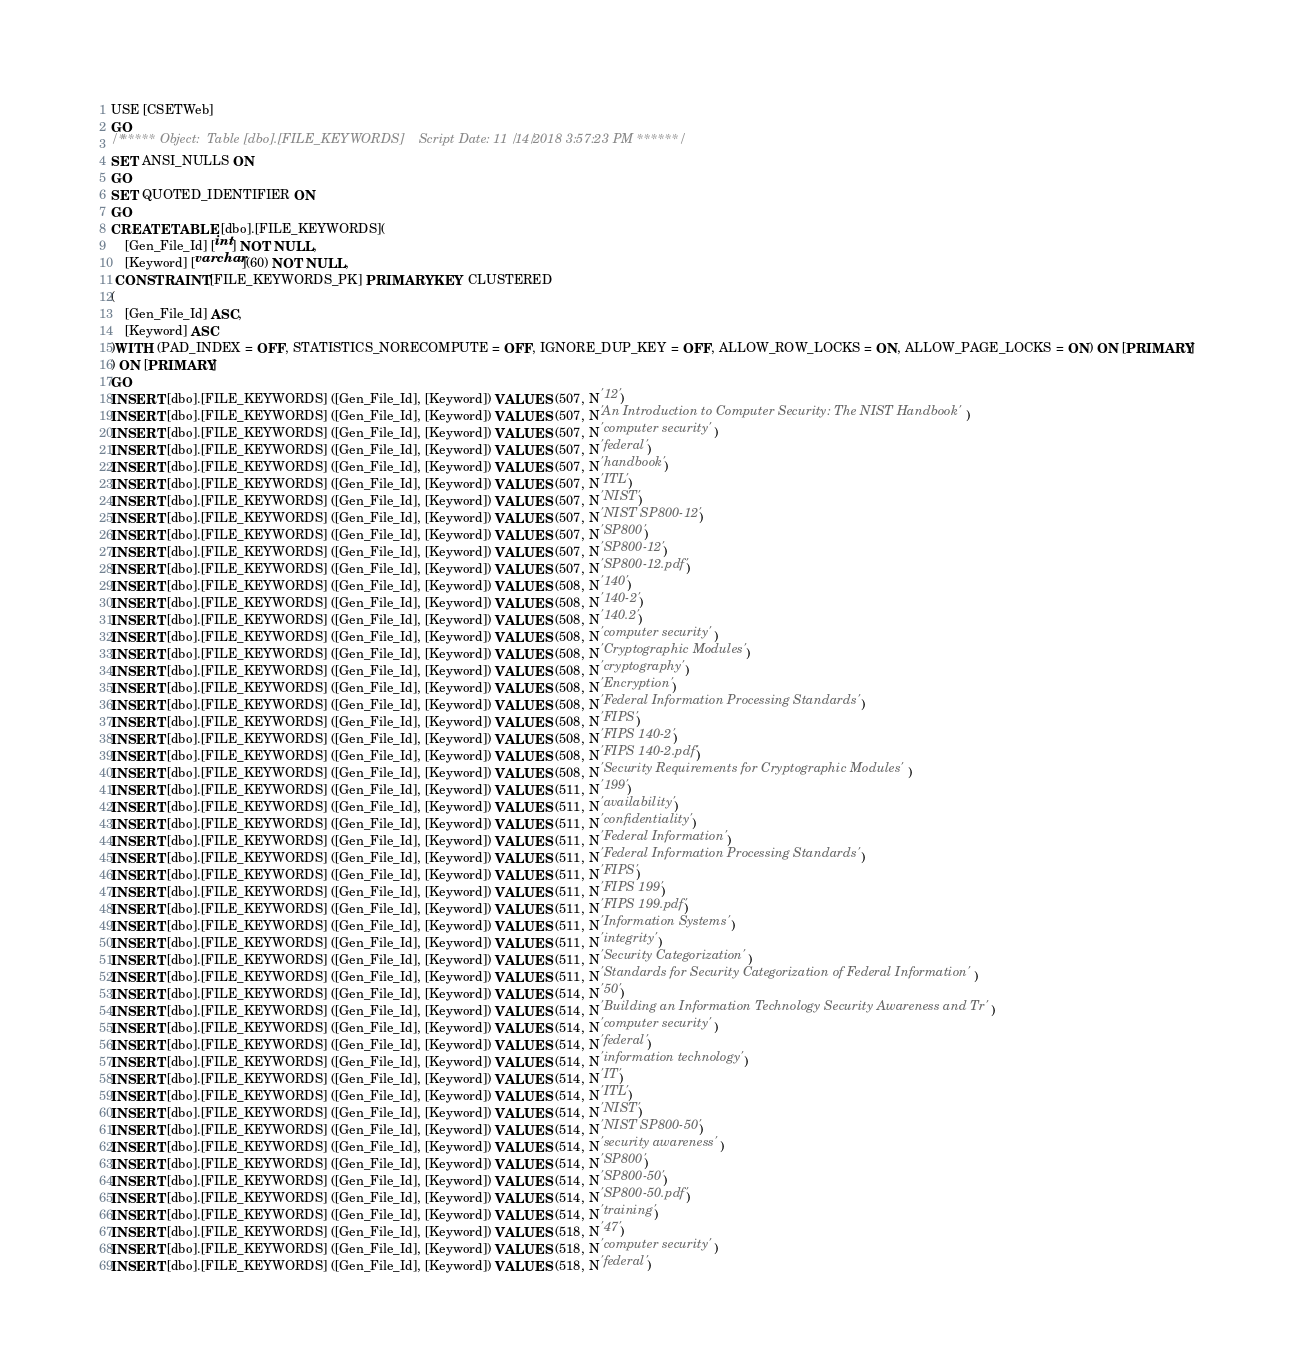<code> <loc_0><loc_0><loc_500><loc_500><_SQL_>USE [CSETWeb]
GO
/****** Object:  Table [dbo].[FILE_KEYWORDS]    Script Date: 11/14/2018 3:57:23 PM ******/
SET ANSI_NULLS ON
GO
SET QUOTED_IDENTIFIER ON
GO
CREATE TABLE [dbo].[FILE_KEYWORDS](
	[Gen_File_Id] [int] NOT NULL,
	[Keyword] [varchar](60) NOT NULL,
 CONSTRAINT [FILE_KEYWORDS_PK] PRIMARY KEY CLUSTERED 
(
	[Gen_File_Id] ASC,
	[Keyword] ASC
)WITH (PAD_INDEX = OFF, STATISTICS_NORECOMPUTE = OFF, IGNORE_DUP_KEY = OFF, ALLOW_ROW_LOCKS = ON, ALLOW_PAGE_LOCKS = ON) ON [PRIMARY]
) ON [PRIMARY]
GO
INSERT [dbo].[FILE_KEYWORDS] ([Gen_File_Id], [Keyword]) VALUES (507, N'12')
INSERT [dbo].[FILE_KEYWORDS] ([Gen_File_Id], [Keyword]) VALUES (507, N'An Introduction to Computer Security: The NIST Handbook')
INSERT [dbo].[FILE_KEYWORDS] ([Gen_File_Id], [Keyword]) VALUES (507, N'computer security')
INSERT [dbo].[FILE_KEYWORDS] ([Gen_File_Id], [Keyword]) VALUES (507, N'federal')
INSERT [dbo].[FILE_KEYWORDS] ([Gen_File_Id], [Keyword]) VALUES (507, N'handbook')
INSERT [dbo].[FILE_KEYWORDS] ([Gen_File_Id], [Keyword]) VALUES (507, N'ITL')
INSERT [dbo].[FILE_KEYWORDS] ([Gen_File_Id], [Keyword]) VALUES (507, N'NIST')
INSERT [dbo].[FILE_KEYWORDS] ([Gen_File_Id], [Keyword]) VALUES (507, N'NIST SP800-12')
INSERT [dbo].[FILE_KEYWORDS] ([Gen_File_Id], [Keyword]) VALUES (507, N'SP800')
INSERT [dbo].[FILE_KEYWORDS] ([Gen_File_Id], [Keyword]) VALUES (507, N'SP800-12')
INSERT [dbo].[FILE_KEYWORDS] ([Gen_File_Id], [Keyword]) VALUES (507, N'SP800-12.pdf')
INSERT [dbo].[FILE_KEYWORDS] ([Gen_File_Id], [Keyword]) VALUES (508, N'140')
INSERT [dbo].[FILE_KEYWORDS] ([Gen_File_Id], [Keyword]) VALUES (508, N'140-2')
INSERT [dbo].[FILE_KEYWORDS] ([Gen_File_Id], [Keyword]) VALUES (508, N'140.2')
INSERT [dbo].[FILE_KEYWORDS] ([Gen_File_Id], [Keyword]) VALUES (508, N'computer security')
INSERT [dbo].[FILE_KEYWORDS] ([Gen_File_Id], [Keyword]) VALUES (508, N'Cryptographic Modules')
INSERT [dbo].[FILE_KEYWORDS] ([Gen_File_Id], [Keyword]) VALUES (508, N'cryptography')
INSERT [dbo].[FILE_KEYWORDS] ([Gen_File_Id], [Keyword]) VALUES (508, N'Encryption')
INSERT [dbo].[FILE_KEYWORDS] ([Gen_File_Id], [Keyword]) VALUES (508, N'Federal Information Processing Standards')
INSERT [dbo].[FILE_KEYWORDS] ([Gen_File_Id], [Keyword]) VALUES (508, N'FIPS')
INSERT [dbo].[FILE_KEYWORDS] ([Gen_File_Id], [Keyword]) VALUES (508, N'FIPS 140-2')
INSERT [dbo].[FILE_KEYWORDS] ([Gen_File_Id], [Keyword]) VALUES (508, N'FIPS 140-2.pdf')
INSERT [dbo].[FILE_KEYWORDS] ([Gen_File_Id], [Keyword]) VALUES (508, N'Security Requirements for Cryptographic Modules')
INSERT [dbo].[FILE_KEYWORDS] ([Gen_File_Id], [Keyword]) VALUES (511, N'199')
INSERT [dbo].[FILE_KEYWORDS] ([Gen_File_Id], [Keyword]) VALUES (511, N'availability')
INSERT [dbo].[FILE_KEYWORDS] ([Gen_File_Id], [Keyword]) VALUES (511, N'confidentiality')
INSERT [dbo].[FILE_KEYWORDS] ([Gen_File_Id], [Keyword]) VALUES (511, N'Federal Information')
INSERT [dbo].[FILE_KEYWORDS] ([Gen_File_Id], [Keyword]) VALUES (511, N'Federal Information Processing Standards')
INSERT [dbo].[FILE_KEYWORDS] ([Gen_File_Id], [Keyword]) VALUES (511, N'FIPS')
INSERT [dbo].[FILE_KEYWORDS] ([Gen_File_Id], [Keyword]) VALUES (511, N'FIPS 199')
INSERT [dbo].[FILE_KEYWORDS] ([Gen_File_Id], [Keyword]) VALUES (511, N'FIPS 199.pdf')
INSERT [dbo].[FILE_KEYWORDS] ([Gen_File_Id], [Keyword]) VALUES (511, N'Information Systems')
INSERT [dbo].[FILE_KEYWORDS] ([Gen_File_Id], [Keyword]) VALUES (511, N'integrity')
INSERT [dbo].[FILE_KEYWORDS] ([Gen_File_Id], [Keyword]) VALUES (511, N'Security Categorization')
INSERT [dbo].[FILE_KEYWORDS] ([Gen_File_Id], [Keyword]) VALUES (511, N'Standards for Security Categorization of Federal Information')
INSERT [dbo].[FILE_KEYWORDS] ([Gen_File_Id], [Keyword]) VALUES (514, N'50')
INSERT [dbo].[FILE_KEYWORDS] ([Gen_File_Id], [Keyword]) VALUES (514, N'Building an Information Technology Security Awareness and Tr')
INSERT [dbo].[FILE_KEYWORDS] ([Gen_File_Id], [Keyword]) VALUES (514, N'computer security')
INSERT [dbo].[FILE_KEYWORDS] ([Gen_File_Id], [Keyword]) VALUES (514, N'federal')
INSERT [dbo].[FILE_KEYWORDS] ([Gen_File_Id], [Keyword]) VALUES (514, N'information technology')
INSERT [dbo].[FILE_KEYWORDS] ([Gen_File_Id], [Keyword]) VALUES (514, N'IT')
INSERT [dbo].[FILE_KEYWORDS] ([Gen_File_Id], [Keyword]) VALUES (514, N'ITL')
INSERT [dbo].[FILE_KEYWORDS] ([Gen_File_Id], [Keyword]) VALUES (514, N'NIST')
INSERT [dbo].[FILE_KEYWORDS] ([Gen_File_Id], [Keyword]) VALUES (514, N'NIST SP800-50')
INSERT [dbo].[FILE_KEYWORDS] ([Gen_File_Id], [Keyword]) VALUES (514, N'security awareness')
INSERT [dbo].[FILE_KEYWORDS] ([Gen_File_Id], [Keyword]) VALUES (514, N'SP800')
INSERT [dbo].[FILE_KEYWORDS] ([Gen_File_Id], [Keyword]) VALUES (514, N'SP800-50')
INSERT [dbo].[FILE_KEYWORDS] ([Gen_File_Id], [Keyword]) VALUES (514, N'SP800-50.pdf')
INSERT [dbo].[FILE_KEYWORDS] ([Gen_File_Id], [Keyword]) VALUES (514, N'training')
INSERT [dbo].[FILE_KEYWORDS] ([Gen_File_Id], [Keyword]) VALUES (518, N'47')
INSERT [dbo].[FILE_KEYWORDS] ([Gen_File_Id], [Keyword]) VALUES (518, N'computer security')
INSERT [dbo].[FILE_KEYWORDS] ([Gen_File_Id], [Keyword]) VALUES (518, N'federal')</code> 